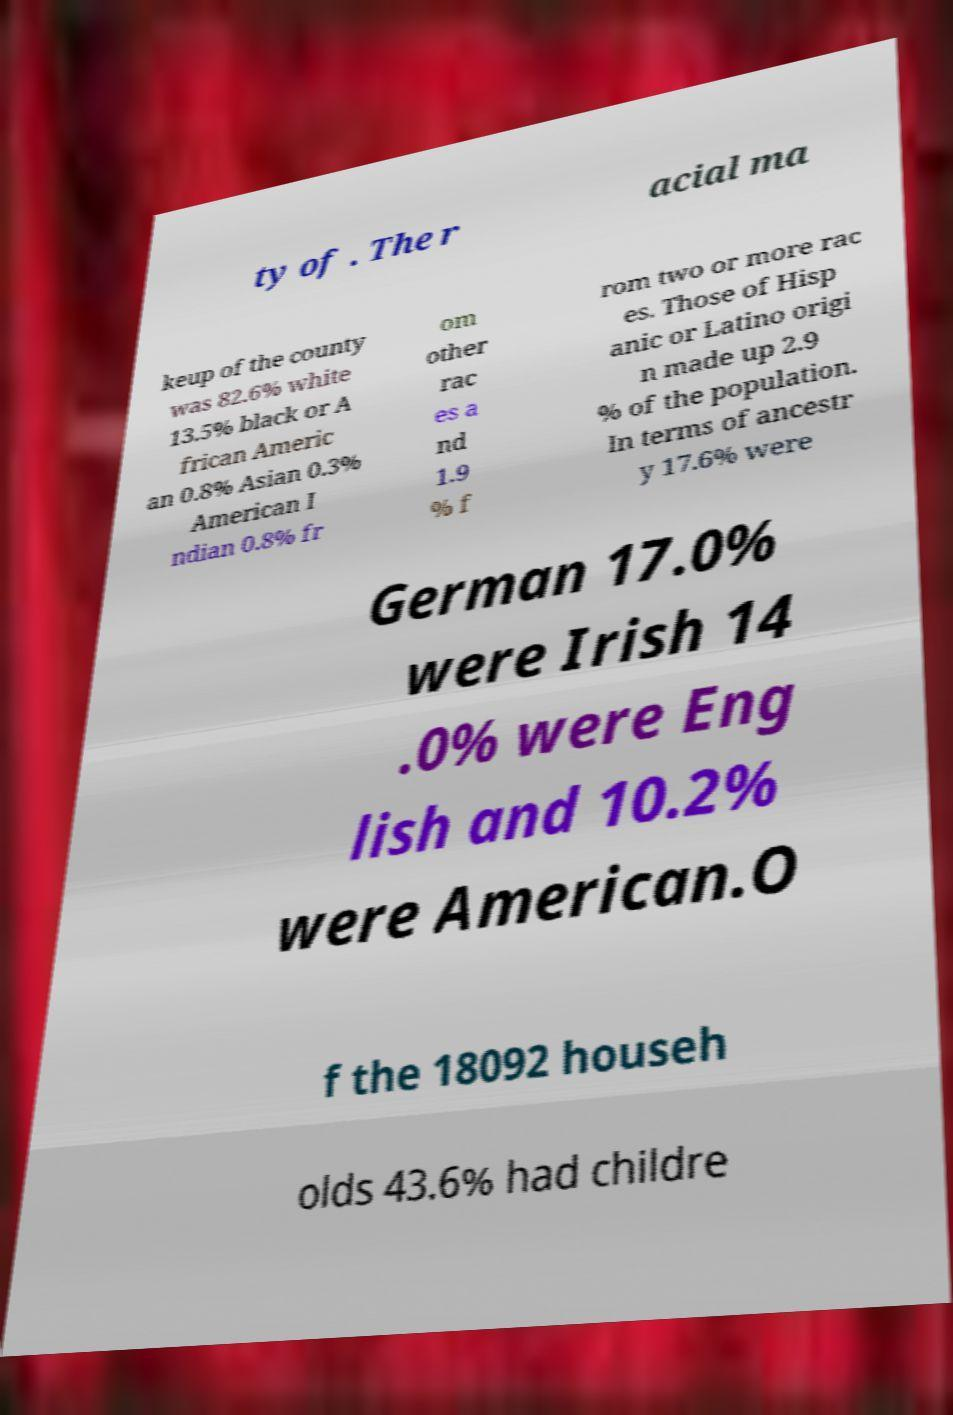Please read and relay the text visible in this image. What does it say? ty of . The r acial ma keup of the county was 82.6% white 13.5% black or A frican Americ an 0.8% Asian 0.3% American I ndian 0.8% fr om other rac es a nd 1.9 % f rom two or more rac es. Those of Hisp anic or Latino origi n made up 2.9 % of the population. In terms of ancestr y 17.6% were German 17.0% were Irish 14 .0% were Eng lish and 10.2% were American.O f the 18092 househ olds 43.6% had childre 